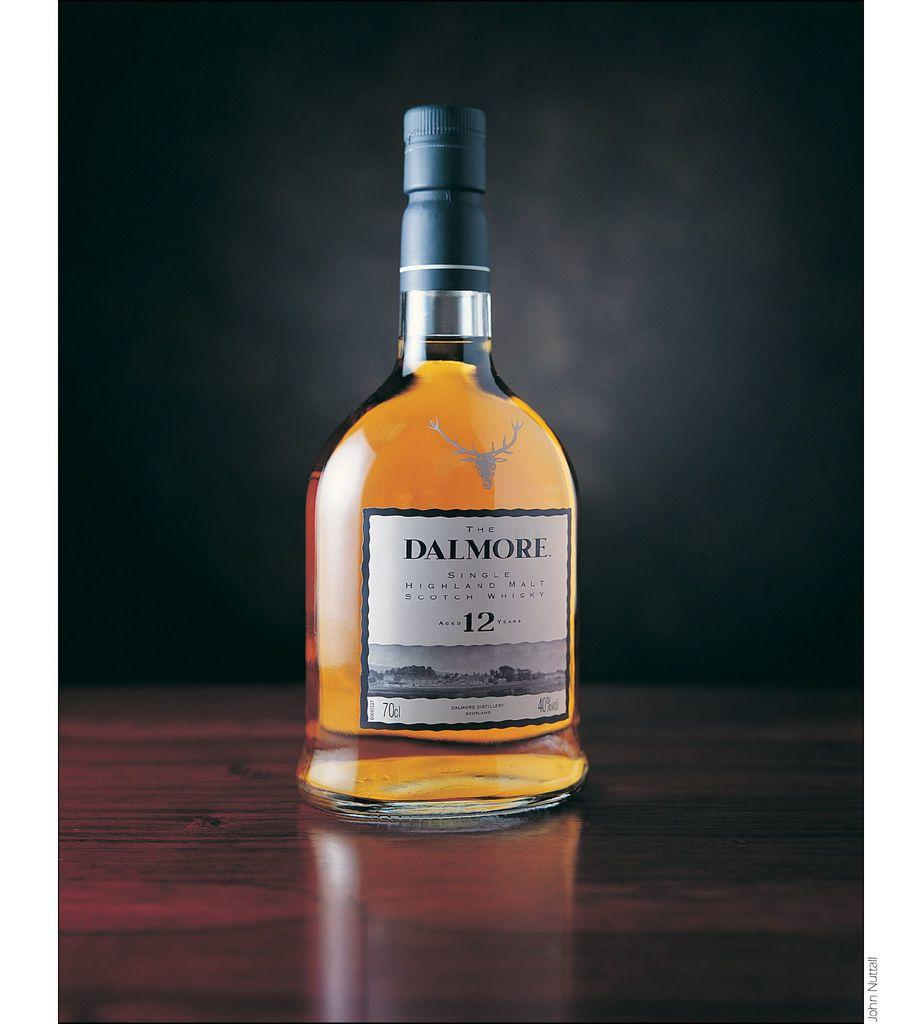<image>
Render a clear and concise summary of the photo. A bottle of light golden Dalmore placed on a table. 